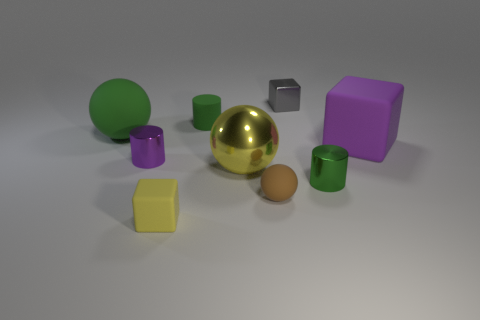Is the number of green objects that are to the right of the tiny purple cylinder greater than the number of large green objects?
Your answer should be compact. Yes. How many big rubber objects have the same color as the tiny rubber cylinder?
Give a very brief answer. 1. What number of other things are the same color as the large matte ball?
Offer a terse response. 2. Is the number of matte blocks greater than the number of big metal objects?
Make the answer very short. Yes. What is the material of the tiny brown ball?
Offer a very short reply. Rubber. There is a cylinder that is behind the purple block; does it have the same size as the small gray thing?
Keep it short and to the point. Yes. There is a matte cube that is right of the gray thing; what size is it?
Your response must be concise. Large. What number of tiny gray things are there?
Offer a very short reply. 1. Is the color of the small matte cylinder the same as the big rubber sphere?
Your response must be concise. Yes. The large thing that is both behind the purple metal thing and to the right of the purple cylinder is what color?
Offer a terse response. Purple. 